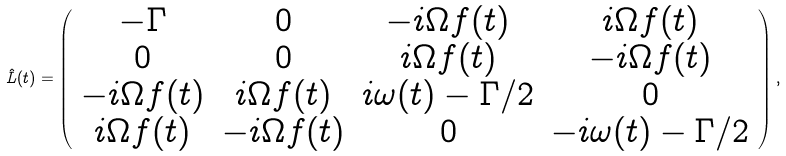<formula> <loc_0><loc_0><loc_500><loc_500>\hat { L } ( t ) = \left ( \begin{array} { c c c c } - \Gamma & 0 & - i \Omega f ( t ) & i \Omega f ( t ) \\ 0 & 0 & i \Omega f ( t ) & - i \Omega f ( t ) \\ - i \Omega f ( t ) & i \Omega f ( t ) & i \omega ( t ) - \Gamma / 2 & 0 \\ i \Omega f ( t ) & - i \Omega f ( t ) & 0 & - i \omega ( t ) - \Gamma / 2 \end{array} \right ) ,</formula> 